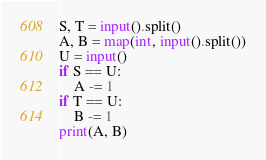<code> <loc_0><loc_0><loc_500><loc_500><_Python_>S, T = input().split()
A, B = map(int, input().split())
U = input()
if S == U:
    A -= 1
if T == U:
    B -= 1
print(A, B)
</code> 